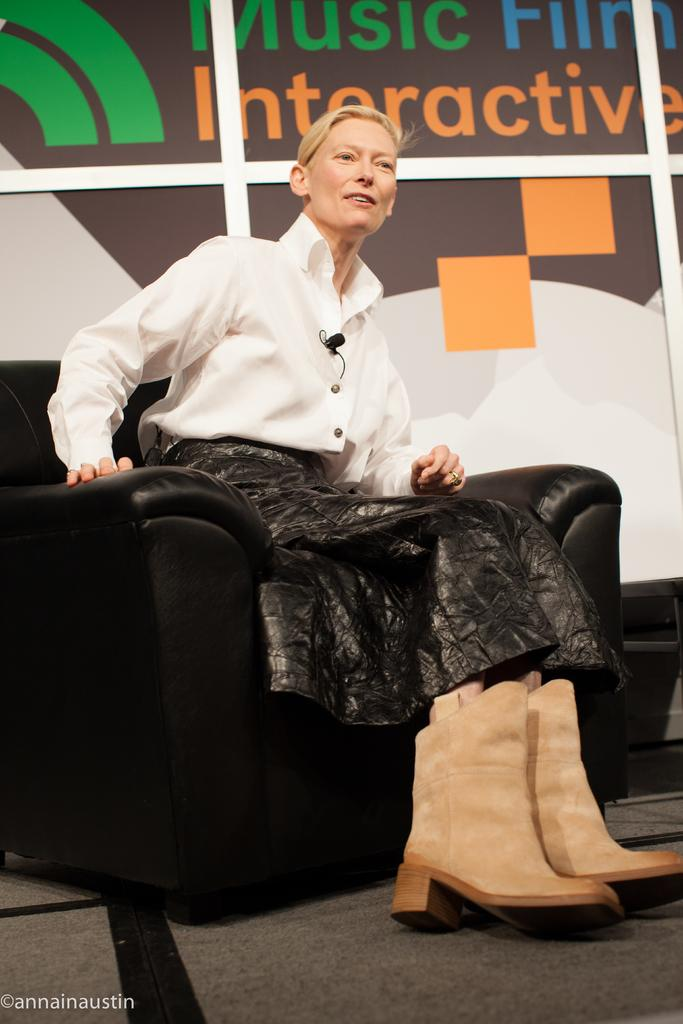Who is present in the image? There is a woman in the image. What is the woman doing in the image? The woman is sitting on a chair. What object can be seen in the image besides the woman and the chair? There is a board visible in the image. How does the woman perform magic tricks with the board in the image? There is no indication in the image that the woman is performing magic tricks or interacting with the board in any way. 